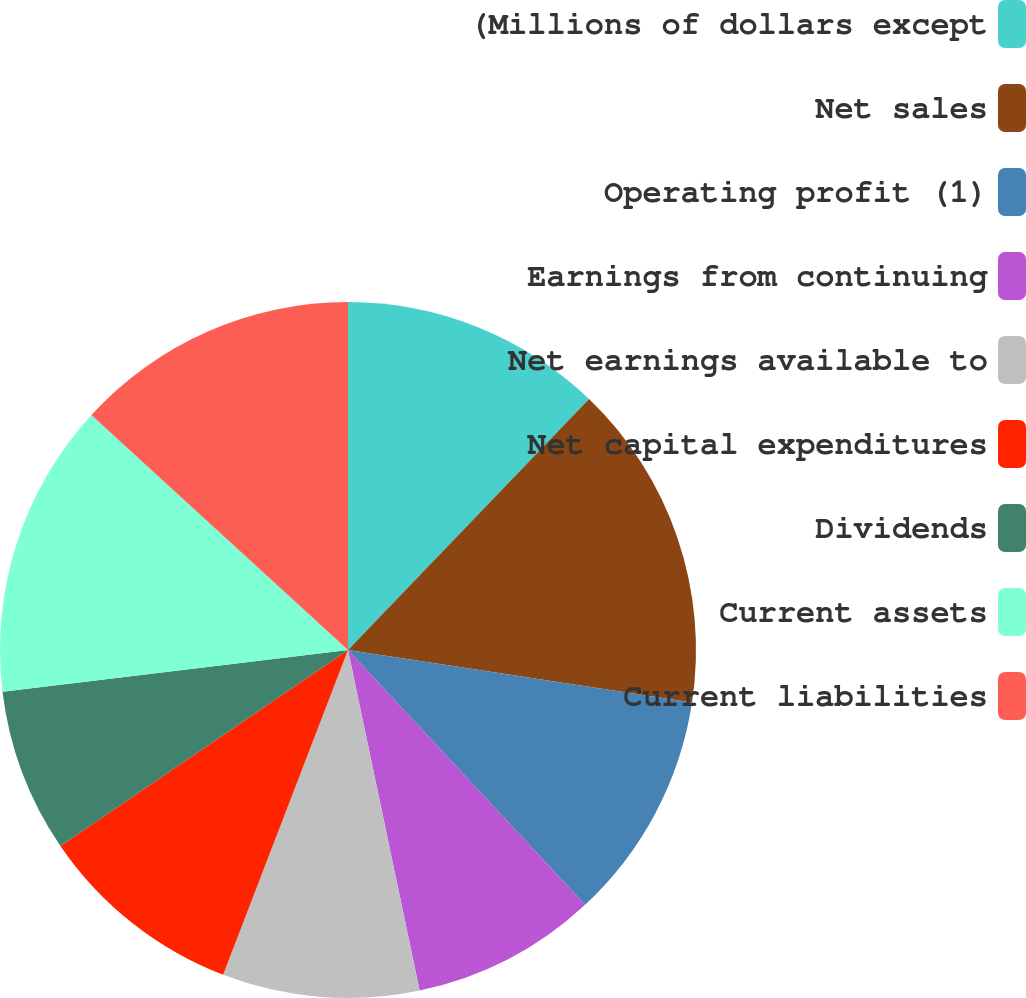Convert chart to OTSL. <chart><loc_0><loc_0><loc_500><loc_500><pie_chart><fcel>(Millions of dollars except<fcel>Net sales<fcel>Operating profit (1)<fcel>Earnings from continuing<fcel>Net earnings available to<fcel>Net capital expenditures<fcel>Dividends<fcel>Current assets<fcel>Current liabilities<nl><fcel>12.18%<fcel>15.23%<fcel>10.66%<fcel>8.63%<fcel>9.14%<fcel>9.64%<fcel>7.61%<fcel>13.71%<fcel>13.2%<nl></chart> 